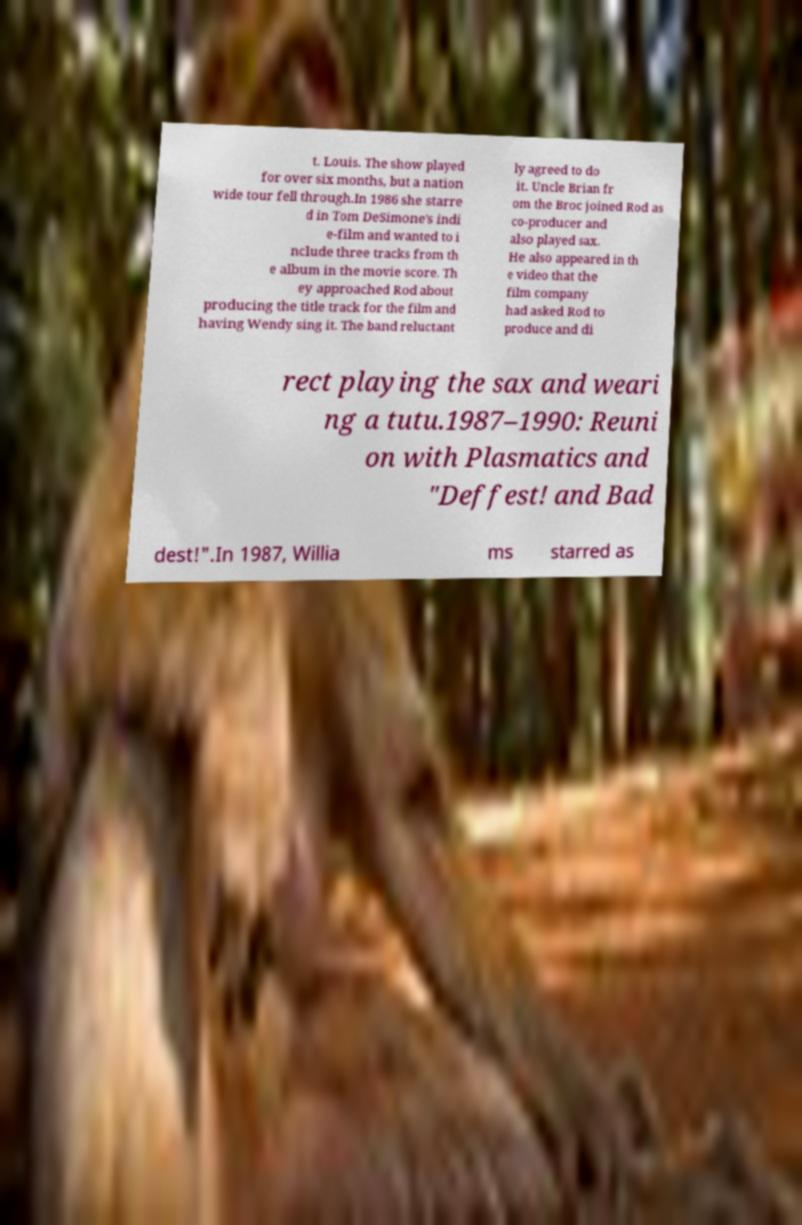Could you extract and type out the text from this image? t. Louis. The show played for over six months, but a nation wide tour fell through.In 1986 she starre d in Tom DeSimone's indi e-film and wanted to i nclude three tracks from th e album in the movie score. Th ey approached Rod about producing the title track for the film and having Wendy sing it. The band reluctant ly agreed to do it. Uncle Brian fr om the Broc joined Rod as co-producer and also played sax. He also appeared in th e video that the film company had asked Rod to produce and di rect playing the sax and weari ng a tutu.1987–1990: Reuni on with Plasmatics and "Deffest! and Bad dest!".In 1987, Willia ms starred as 